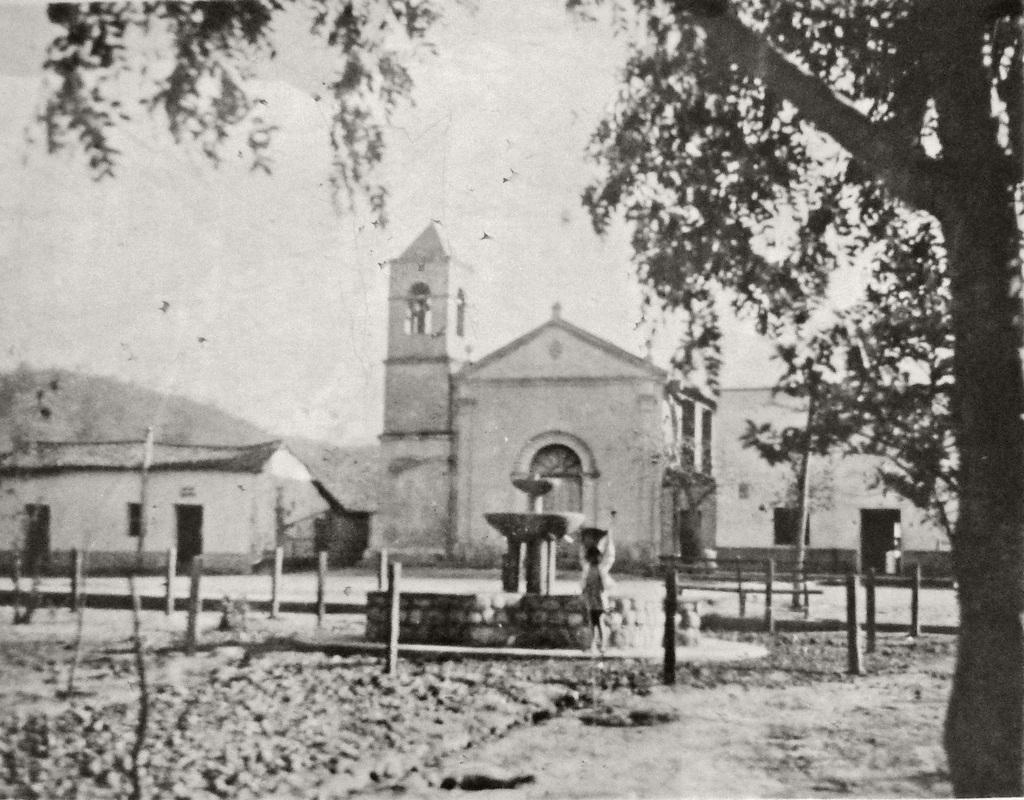Could you give a brief overview of what you see in this image? In this image I can see there is a fountain, wooden poles, a tree at the right side and there are few buildings in the background. I can see the sky is clear, the image is in black and white color and it is blurred. 